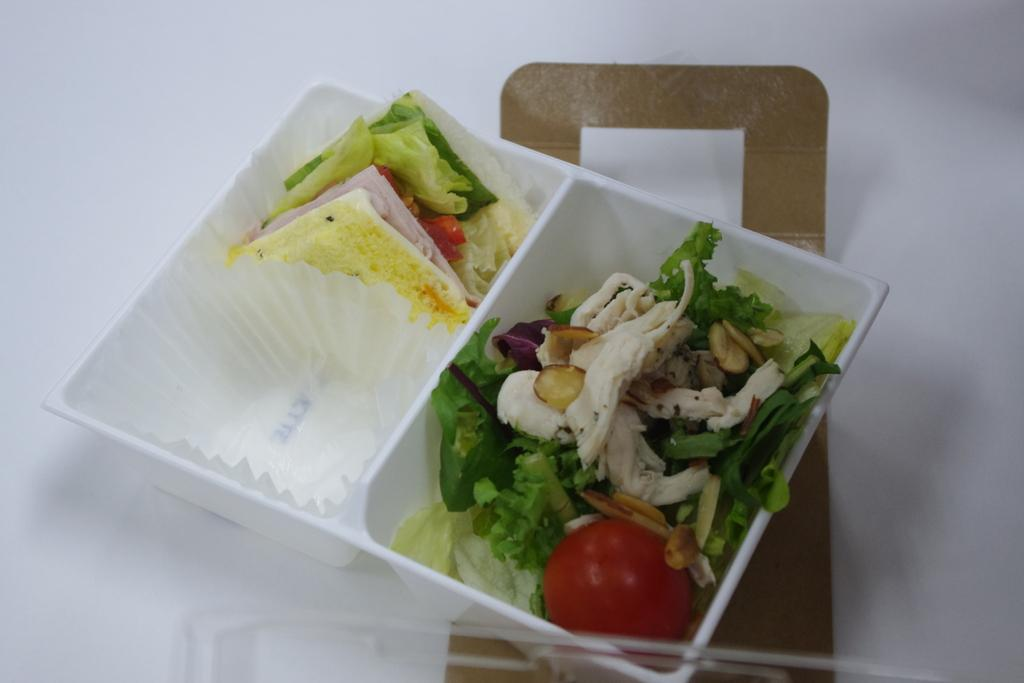What is present in the image related to food? There is food in the image. How is the food contained or stored in the image? The food is in a plastic box. What type of fowl can be seen celebrating a birthday in the image? There is no fowl or birthday celebration present in the image; it only features food in a plastic box. Can you identify any visible veins in the image? There are no visible veins in the image, as it only contains food in a plastic box. 